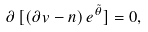<formula> <loc_0><loc_0><loc_500><loc_500>\partial \, [ ( \partial v - { n } ) \, e ^ { \tilde { \theta } } ] = 0 ,</formula> 